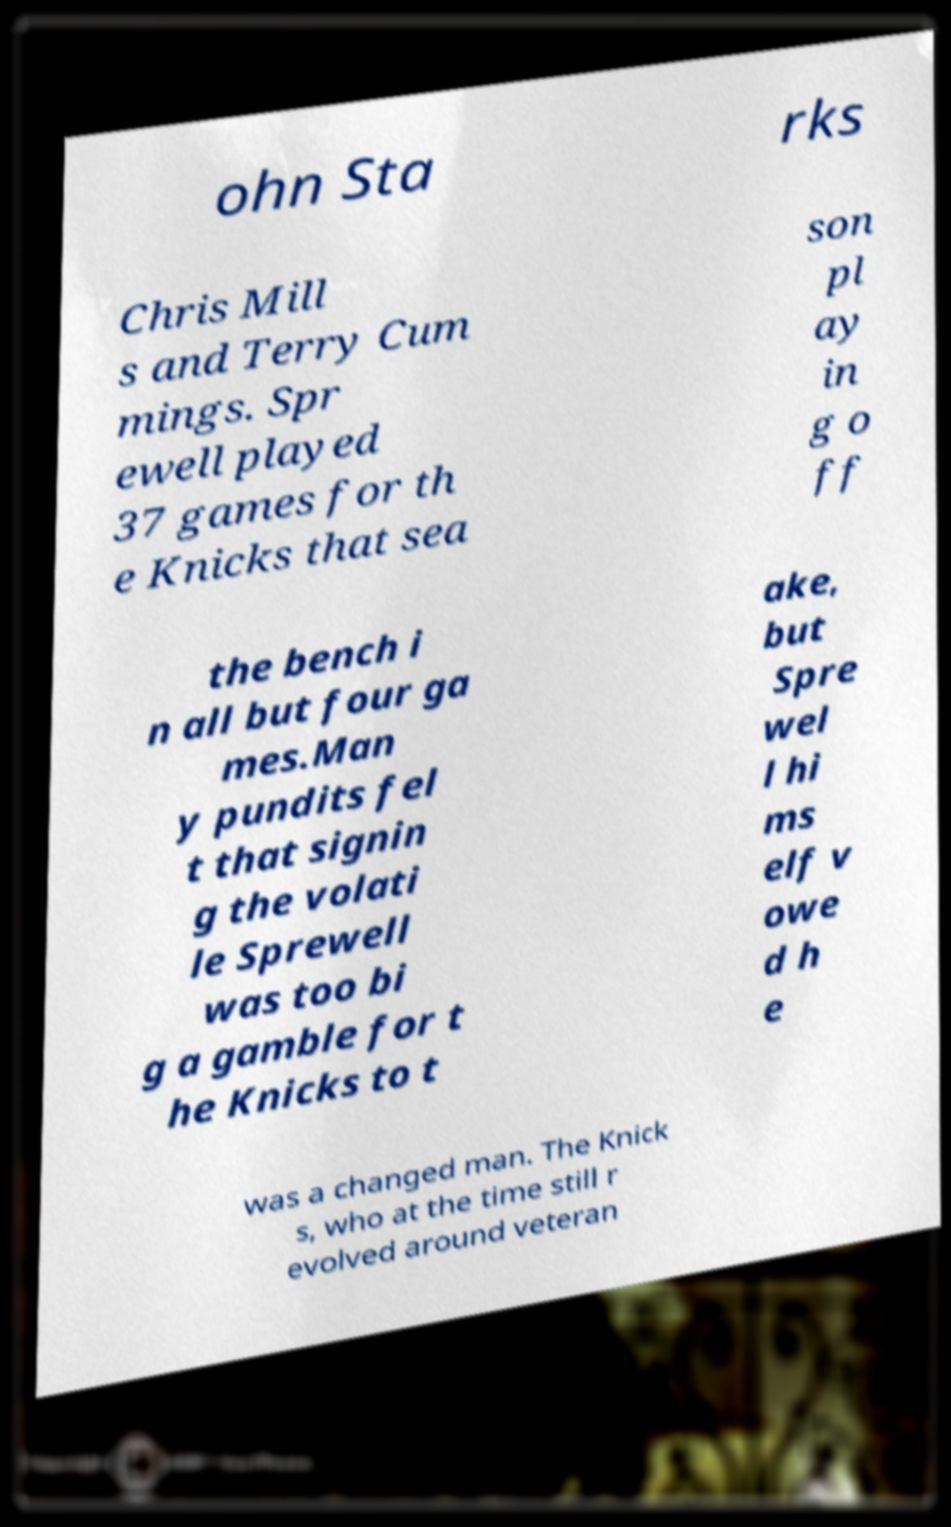There's text embedded in this image that I need extracted. Can you transcribe it verbatim? ohn Sta rks Chris Mill s and Terry Cum mings. Spr ewell played 37 games for th e Knicks that sea son pl ay in g o ff the bench i n all but four ga mes.Man y pundits fel t that signin g the volati le Sprewell was too bi g a gamble for t he Knicks to t ake, but Spre wel l hi ms elf v owe d h e was a changed man. The Knick s, who at the time still r evolved around veteran 